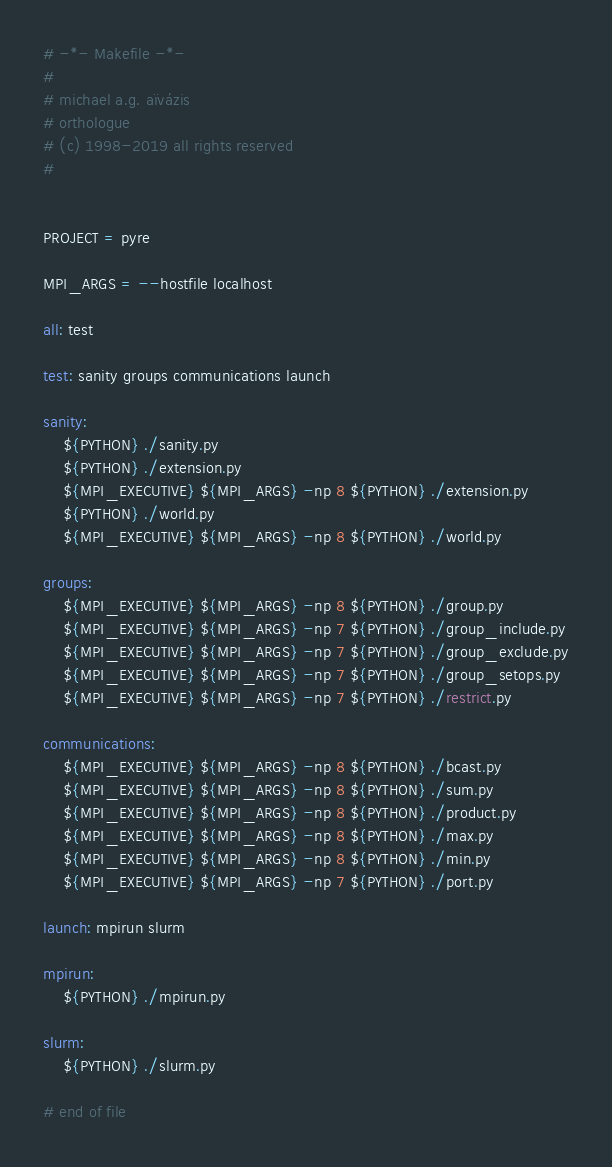<code> <loc_0><loc_0><loc_500><loc_500><_ObjectiveC_># -*- Makefile -*-
#
# michael a.g. aïvázis
# orthologue
# (c) 1998-2019 all rights reserved
#


PROJECT = pyre

MPI_ARGS = --hostfile localhost

all: test

test: sanity groups communications launch

sanity:
	${PYTHON} ./sanity.py
	${PYTHON} ./extension.py
	${MPI_EXECUTIVE} ${MPI_ARGS} -np 8 ${PYTHON} ./extension.py
	${PYTHON} ./world.py
	${MPI_EXECUTIVE} ${MPI_ARGS} -np 8 ${PYTHON} ./world.py

groups:
	${MPI_EXECUTIVE} ${MPI_ARGS} -np 8 ${PYTHON} ./group.py
	${MPI_EXECUTIVE} ${MPI_ARGS} -np 7 ${PYTHON} ./group_include.py
	${MPI_EXECUTIVE} ${MPI_ARGS} -np 7 ${PYTHON} ./group_exclude.py
	${MPI_EXECUTIVE} ${MPI_ARGS} -np 7 ${PYTHON} ./group_setops.py
	${MPI_EXECUTIVE} ${MPI_ARGS} -np 7 ${PYTHON} ./restrict.py

communications:
	${MPI_EXECUTIVE} ${MPI_ARGS} -np 8 ${PYTHON} ./bcast.py
	${MPI_EXECUTIVE} ${MPI_ARGS} -np 8 ${PYTHON} ./sum.py
	${MPI_EXECUTIVE} ${MPI_ARGS} -np 8 ${PYTHON} ./product.py
	${MPI_EXECUTIVE} ${MPI_ARGS} -np 8 ${PYTHON} ./max.py
	${MPI_EXECUTIVE} ${MPI_ARGS} -np 8 ${PYTHON} ./min.py
	${MPI_EXECUTIVE} ${MPI_ARGS} -np 7 ${PYTHON} ./port.py

launch: mpirun slurm

mpirun:
	${PYTHON} ./mpirun.py

slurm:
	${PYTHON} ./slurm.py

# end of file
</code> 